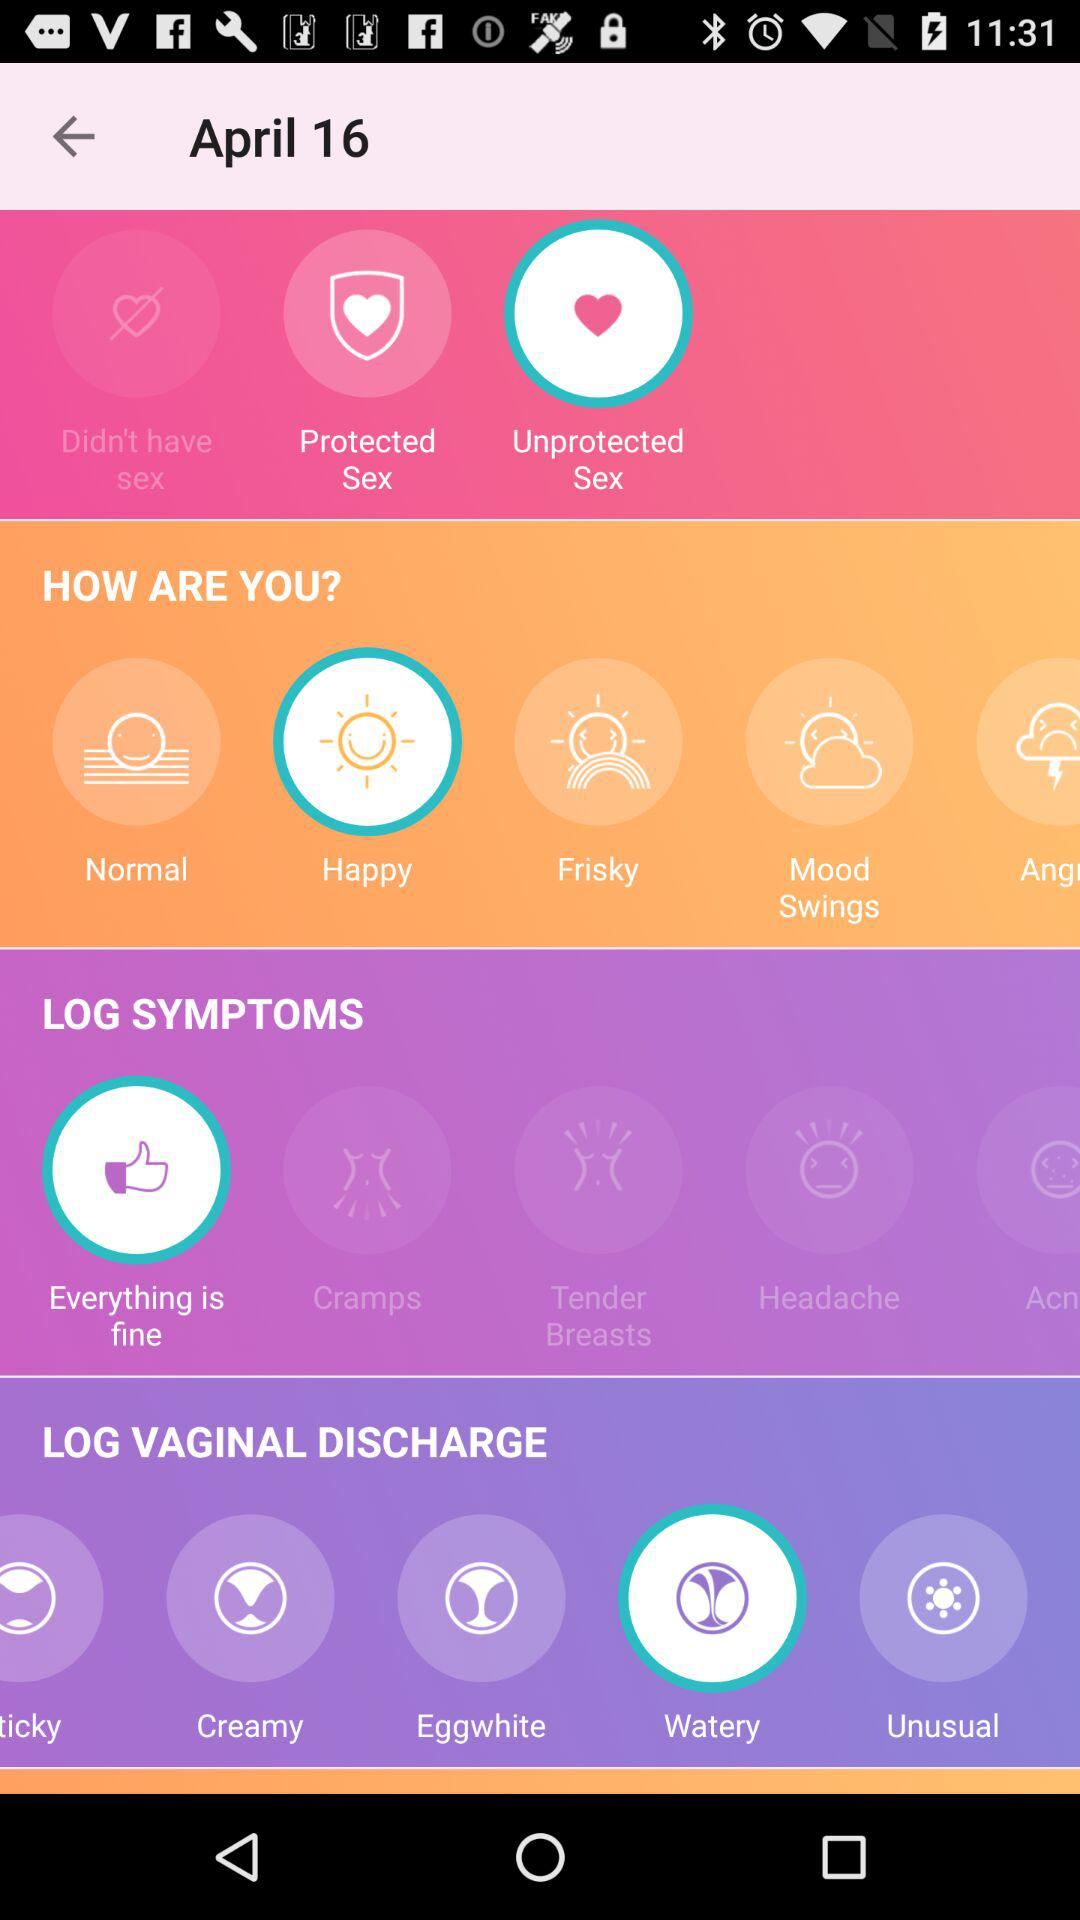What is the status of "LOG VAGINAL DISCHARGE"? The status of "LOG VAGINAL DISCHARGE" is "watery". 